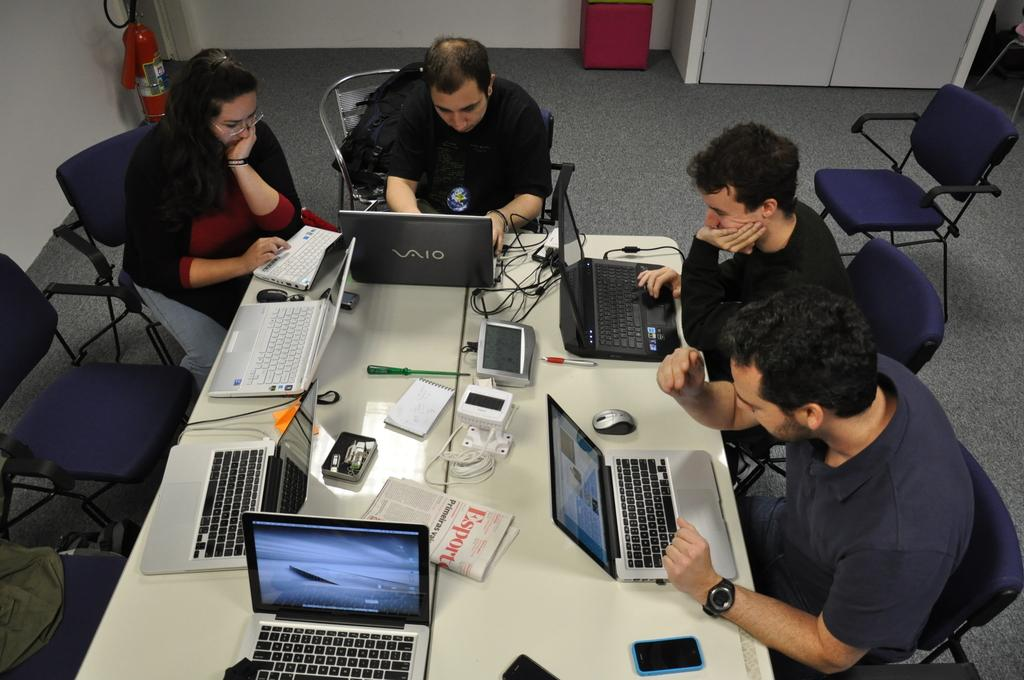Provide a one-sentence caption for the provided image. Workers use Vaio technology to complete their work. 